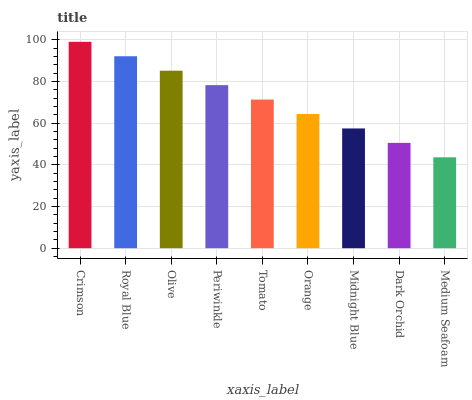Is Royal Blue the minimum?
Answer yes or no. No. Is Royal Blue the maximum?
Answer yes or no. No. Is Crimson greater than Royal Blue?
Answer yes or no. Yes. Is Royal Blue less than Crimson?
Answer yes or no. Yes. Is Royal Blue greater than Crimson?
Answer yes or no. No. Is Crimson less than Royal Blue?
Answer yes or no. No. Is Tomato the high median?
Answer yes or no. Yes. Is Tomato the low median?
Answer yes or no. Yes. Is Dark Orchid the high median?
Answer yes or no. No. Is Olive the low median?
Answer yes or no. No. 